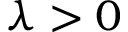Convert formula to latex. <formula><loc_0><loc_0><loc_500><loc_500>\lambda > 0</formula> 